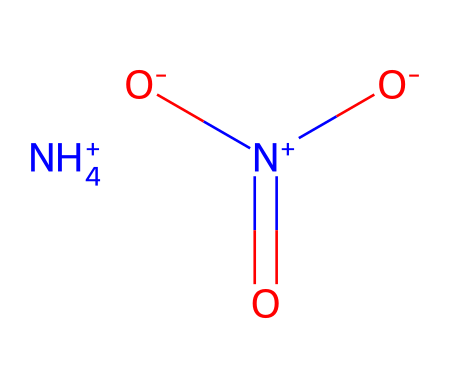What is the chemical name of this compound? The SMILES representation corresponds to ammonium nitrate, which is composed of an ammonium ion (NH4+) and a nitrate ion (NO3-).
Answer: ammonium nitrate How many nitrogen atoms are present in this molecule? The SMILES structure includes one nitrogen atom in the ammonium ion (NH4+) and one in the nitrate ion (NO3-), totaling two nitrogen atoms.
Answer: 2 What is the charge of the ammonium ion in this compound? The ammonium ion is indicated by the notation [NH4+], which signifies it has a positive charge.
Answer: positive Is ammonium nitrate an oxidizer? Ammonium nitrate is classified as an oxidizer due to its ability to release oxygen when decomposed, which supports combustion.
Answer: yes How many oxygen atoms are there in the nitrate ion? The nitrate ion is represented as [N+](=O)([O-])[O-], showing there are three oxygen atoms attached to the nitrogen atom in that ion.
Answer: 3 What type of chemical bond holds the nitrogen and oxygen in the nitrate ion? The nitrogen-oxygen bonds in the nitrate ion comprise both double and single bonds, with one nitrogen atom double-bonded to one oxygen, and single-bonded to the other two oxygens.
Answer: covalent What role does ammonium nitrate play in first aid cold packs? Ammonium nitrate is used in cold packs because it dissolves in water, absorbing heat from the surroundings, and thus creating a cooling effect for first aid applications.
Answer: cooling agent 